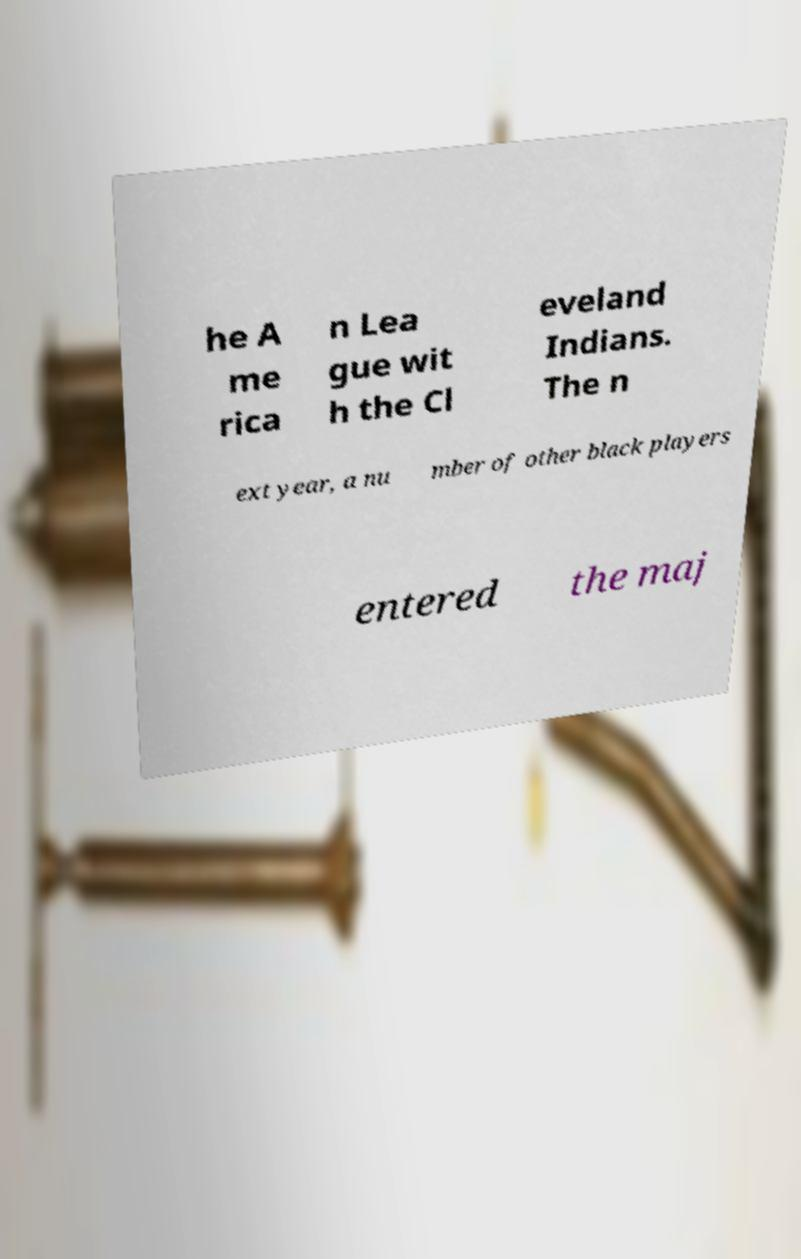I need the written content from this picture converted into text. Can you do that? he A me rica n Lea gue wit h the Cl eveland Indians. The n ext year, a nu mber of other black players entered the maj 